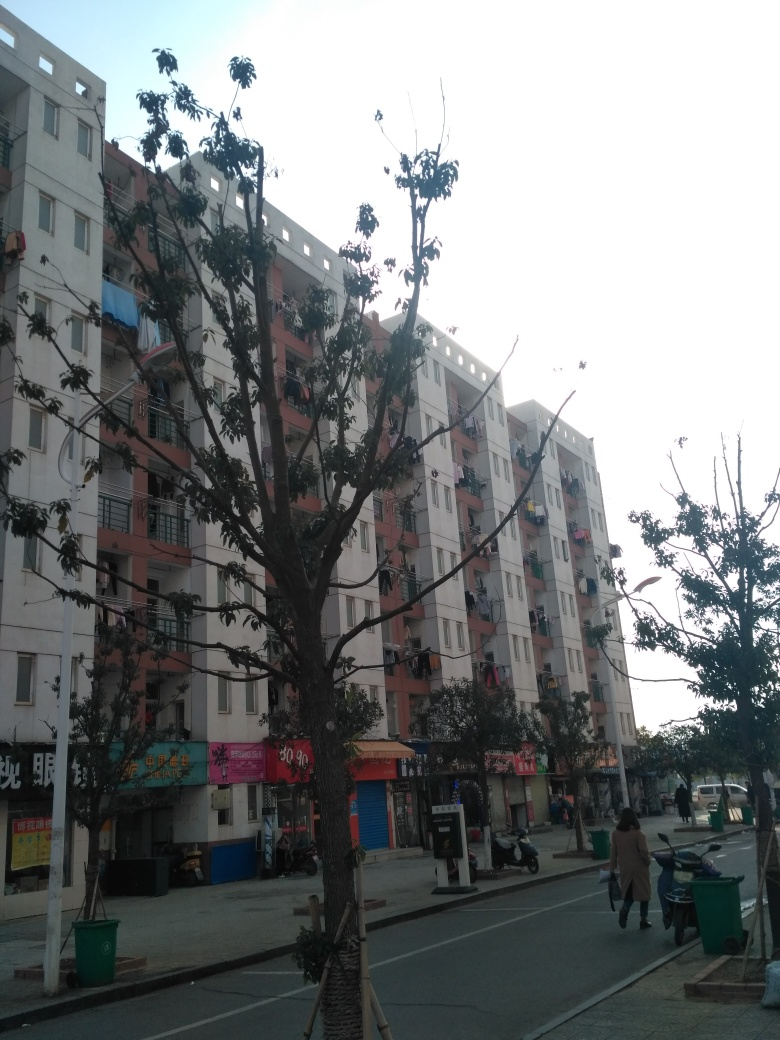Can you tell me more about the architectural style of the building in the image? The building in the image illustrates a typical modern, functional residential design. It lacks distinguishable architectural flourishes and seems to prioritize housing capacity and practicality. The straightforward, boxy structure and use of balconies for each unit suggest a focus on providing private outdoor space within a high-density living arrangement. 